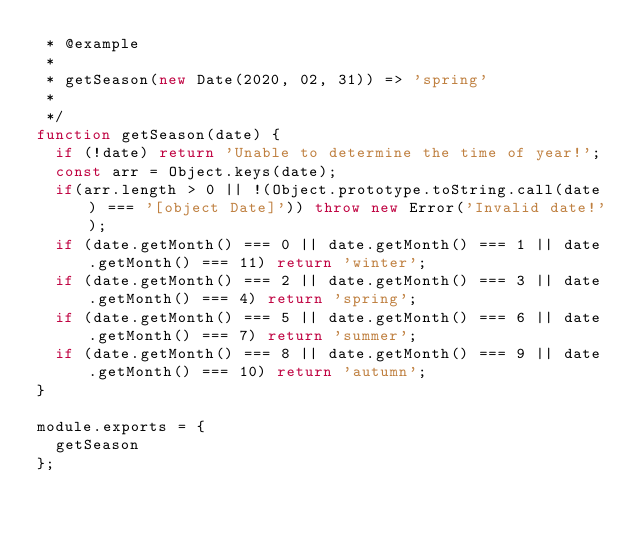Convert code to text. <code><loc_0><loc_0><loc_500><loc_500><_JavaScript_> * @example
 * 
 * getSeason(new Date(2020, 02, 31)) => 'spring'
 * 
 */
function getSeason(date) {
  if (!date) return 'Unable to determine the time of year!';
  const arr = Object.keys(date);
  if(arr.length > 0 || !(Object.prototype.toString.call(date) === '[object Date]')) throw new Error('Invalid date!');
  if (date.getMonth() === 0 || date.getMonth() === 1 || date.getMonth() === 11) return 'winter';
  if (date.getMonth() === 2 || date.getMonth() === 3 || date.getMonth() === 4) return 'spring';
  if (date.getMonth() === 5 || date.getMonth() === 6 || date.getMonth() === 7) return 'summer';
  if (date.getMonth() === 8 || date.getMonth() === 9 || date.getMonth() === 10) return 'autumn';
}

module.exports = {
  getSeason
};
</code> 